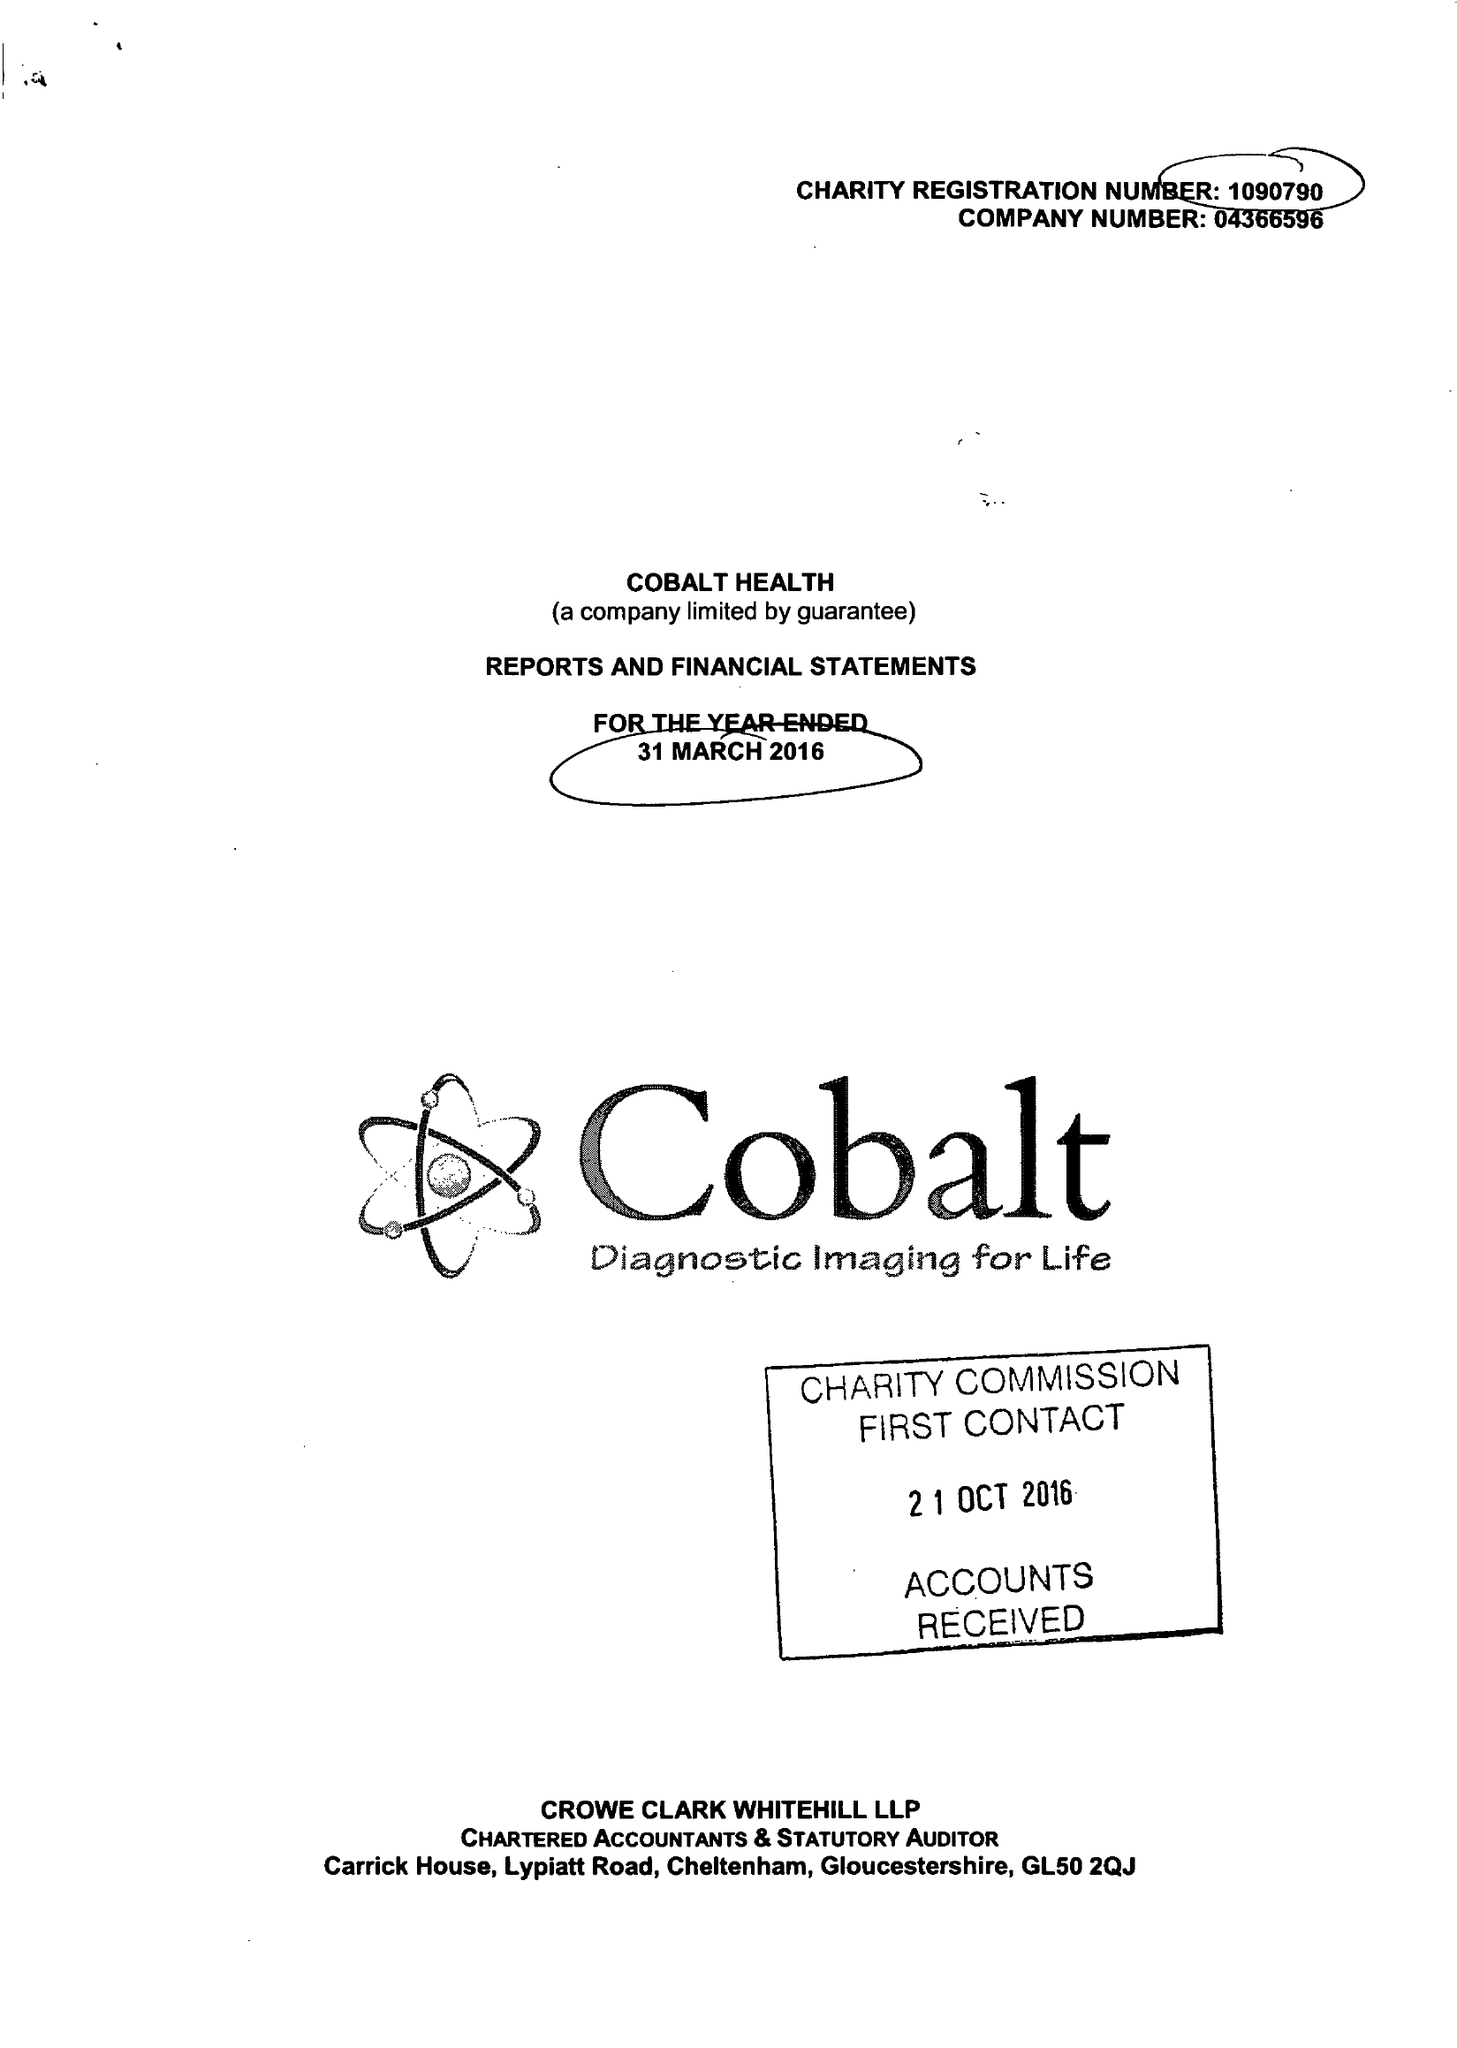What is the value for the spending_annually_in_british_pounds?
Answer the question using a single word or phrase. 7823970.00 